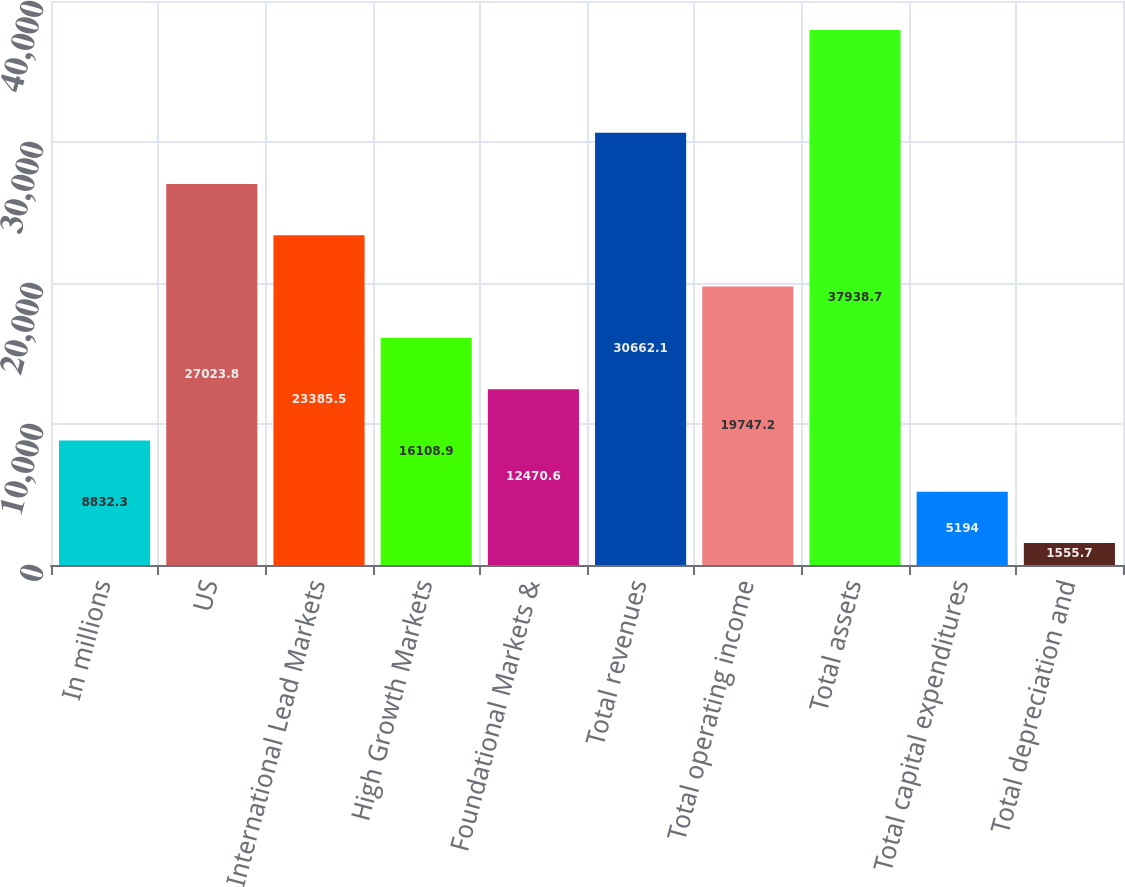<chart> <loc_0><loc_0><loc_500><loc_500><bar_chart><fcel>In millions<fcel>US<fcel>International Lead Markets<fcel>High Growth Markets<fcel>Foundational Markets &<fcel>Total revenues<fcel>Total operating income<fcel>Total assets<fcel>Total capital expenditures<fcel>Total depreciation and<nl><fcel>8832.3<fcel>27023.8<fcel>23385.5<fcel>16108.9<fcel>12470.6<fcel>30662.1<fcel>19747.2<fcel>37938.7<fcel>5194<fcel>1555.7<nl></chart> 